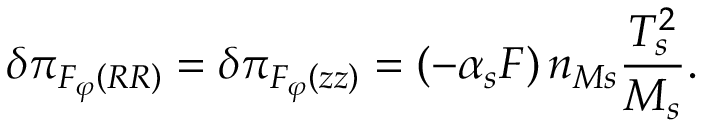<formula> <loc_0><loc_0><loc_500><loc_500>\delta \pi _ { F _ { \varphi } \left ( R R \right ) } = \delta \pi _ { F _ { \varphi } \left ( z z \right ) } = \left ( - \alpha _ { s } F \right ) n _ { M s } \frac { T _ { s } ^ { 2 } } { M _ { s } } .</formula> 